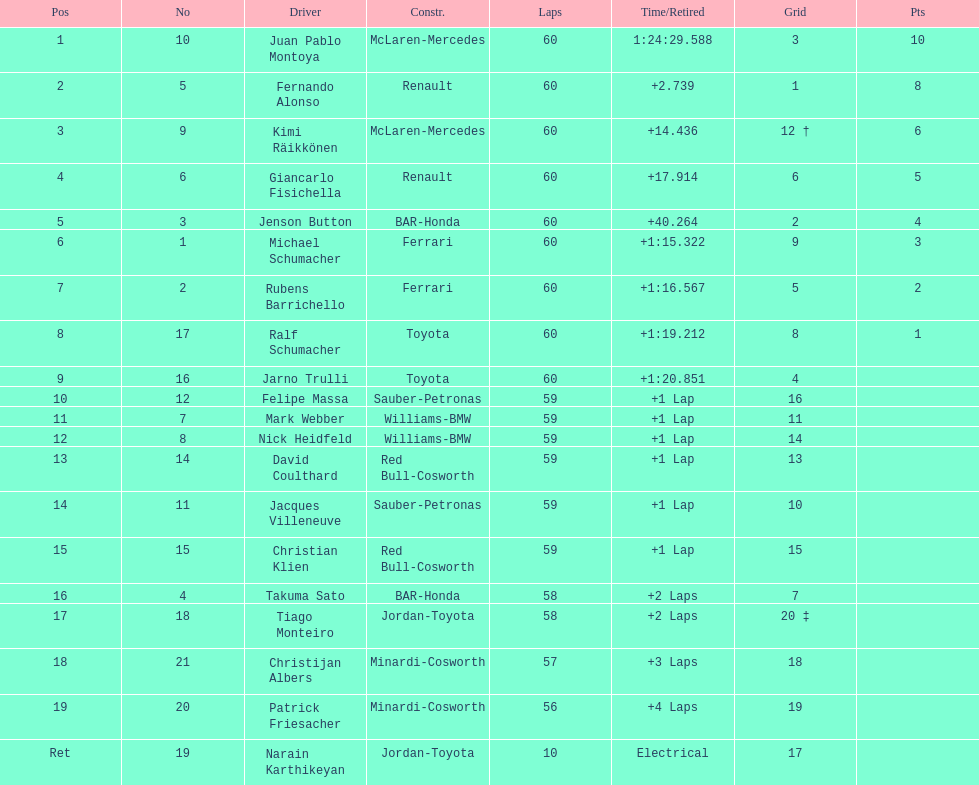Which driver came after giancarlo fisichella? Jenson Button. 